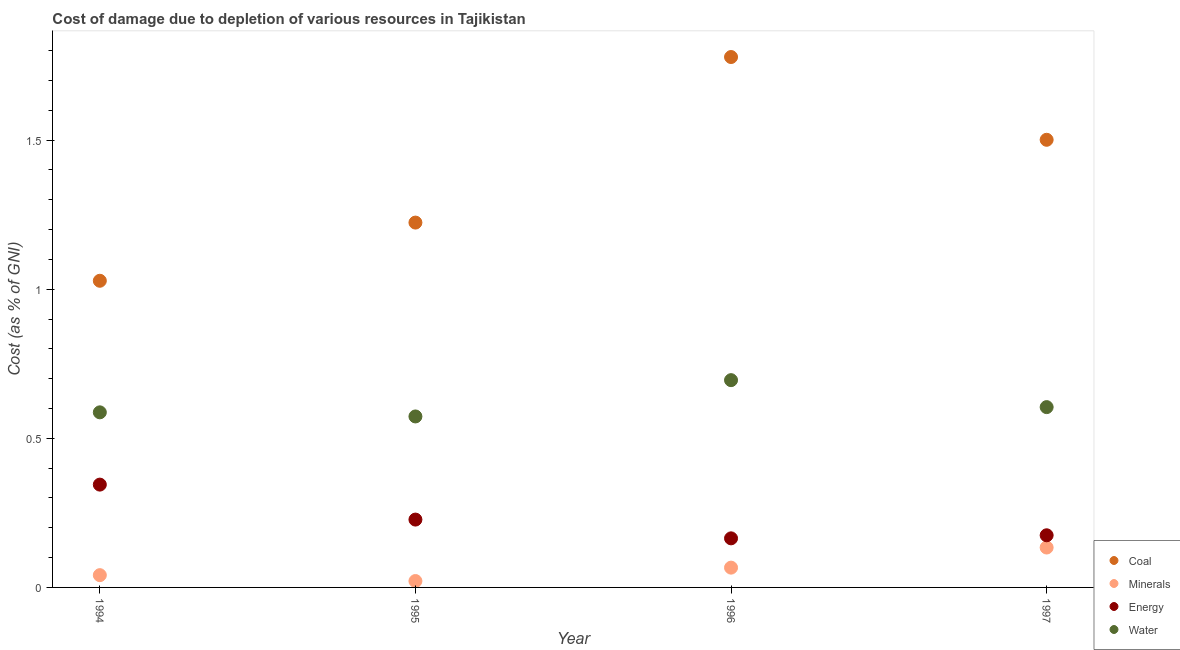What is the cost of damage due to depletion of coal in 1994?
Make the answer very short. 1.03. Across all years, what is the maximum cost of damage due to depletion of minerals?
Offer a terse response. 0.13. Across all years, what is the minimum cost of damage due to depletion of water?
Provide a short and direct response. 0.57. In which year was the cost of damage due to depletion of water maximum?
Offer a terse response. 1996. What is the total cost of damage due to depletion of minerals in the graph?
Your answer should be compact. 0.26. What is the difference between the cost of damage due to depletion of water in 1994 and that in 1996?
Offer a terse response. -0.11. What is the difference between the cost of damage due to depletion of minerals in 1997 and the cost of damage due to depletion of energy in 1994?
Ensure brevity in your answer.  -0.21. What is the average cost of damage due to depletion of energy per year?
Provide a succinct answer. 0.23. In the year 1996, what is the difference between the cost of damage due to depletion of energy and cost of damage due to depletion of minerals?
Keep it short and to the point. 0.1. What is the ratio of the cost of damage due to depletion of coal in 1994 to that in 1997?
Your answer should be very brief. 0.69. Is the difference between the cost of damage due to depletion of energy in 1994 and 1997 greater than the difference between the cost of damage due to depletion of minerals in 1994 and 1997?
Offer a terse response. Yes. What is the difference between the highest and the second highest cost of damage due to depletion of minerals?
Provide a succinct answer. 0.07. What is the difference between the highest and the lowest cost of damage due to depletion of water?
Keep it short and to the point. 0.12. Does the cost of damage due to depletion of coal monotonically increase over the years?
Your answer should be compact. No. Is the cost of damage due to depletion of energy strictly greater than the cost of damage due to depletion of minerals over the years?
Your answer should be very brief. Yes. Are the values on the major ticks of Y-axis written in scientific E-notation?
Give a very brief answer. No. Does the graph contain grids?
Give a very brief answer. No. What is the title of the graph?
Make the answer very short. Cost of damage due to depletion of various resources in Tajikistan . Does "Taxes on revenue" appear as one of the legend labels in the graph?
Your response must be concise. No. What is the label or title of the X-axis?
Ensure brevity in your answer.  Year. What is the label or title of the Y-axis?
Your response must be concise. Cost (as % of GNI). What is the Cost (as % of GNI) of Coal in 1994?
Offer a terse response. 1.03. What is the Cost (as % of GNI) of Minerals in 1994?
Make the answer very short. 0.04. What is the Cost (as % of GNI) of Energy in 1994?
Your answer should be very brief. 0.34. What is the Cost (as % of GNI) of Water in 1994?
Provide a succinct answer. 0.59. What is the Cost (as % of GNI) of Coal in 1995?
Provide a succinct answer. 1.22. What is the Cost (as % of GNI) in Minerals in 1995?
Offer a very short reply. 0.02. What is the Cost (as % of GNI) of Energy in 1995?
Your answer should be very brief. 0.23. What is the Cost (as % of GNI) of Water in 1995?
Ensure brevity in your answer.  0.57. What is the Cost (as % of GNI) of Coal in 1996?
Provide a succinct answer. 1.78. What is the Cost (as % of GNI) of Minerals in 1996?
Provide a short and direct response. 0.07. What is the Cost (as % of GNI) of Energy in 1996?
Keep it short and to the point. 0.16. What is the Cost (as % of GNI) of Water in 1996?
Provide a short and direct response. 0.7. What is the Cost (as % of GNI) of Coal in 1997?
Offer a very short reply. 1.5. What is the Cost (as % of GNI) in Minerals in 1997?
Offer a very short reply. 0.13. What is the Cost (as % of GNI) in Energy in 1997?
Keep it short and to the point. 0.17. What is the Cost (as % of GNI) of Water in 1997?
Offer a very short reply. 0.6. Across all years, what is the maximum Cost (as % of GNI) of Coal?
Ensure brevity in your answer.  1.78. Across all years, what is the maximum Cost (as % of GNI) of Minerals?
Give a very brief answer. 0.13. Across all years, what is the maximum Cost (as % of GNI) of Energy?
Provide a short and direct response. 0.34. Across all years, what is the maximum Cost (as % of GNI) of Water?
Keep it short and to the point. 0.7. Across all years, what is the minimum Cost (as % of GNI) in Coal?
Your response must be concise. 1.03. Across all years, what is the minimum Cost (as % of GNI) of Minerals?
Keep it short and to the point. 0.02. Across all years, what is the minimum Cost (as % of GNI) in Energy?
Ensure brevity in your answer.  0.16. Across all years, what is the minimum Cost (as % of GNI) of Water?
Ensure brevity in your answer.  0.57. What is the total Cost (as % of GNI) of Coal in the graph?
Give a very brief answer. 5.53. What is the total Cost (as % of GNI) in Minerals in the graph?
Offer a very short reply. 0.26. What is the total Cost (as % of GNI) in Energy in the graph?
Your answer should be very brief. 0.91. What is the total Cost (as % of GNI) in Water in the graph?
Provide a succinct answer. 2.46. What is the difference between the Cost (as % of GNI) of Coal in 1994 and that in 1995?
Keep it short and to the point. -0.2. What is the difference between the Cost (as % of GNI) in Minerals in 1994 and that in 1995?
Provide a succinct answer. 0.02. What is the difference between the Cost (as % of GNI) of Energy in 1994 and that in 1995?
Keep it short and to the point. 0.12. What is the difference between the Cost (as % of GNI) of Water in 1994 and that in 1995?
Keep it short and to the point. 0.01. What is the difference between the Cost (as % of GNI) of Coal in 1994 and that in 1996?
Offer a terse response. -0.75. What is the difference between the Cost (as % of GNI) in Minerals in 1994 and that in 1996?
Provide a short and direct response. -0.03. What is the difference between the Cost (as % of GNI) in Energy in 1994 and that in 1996?
Your response must be concise. 0.18. What is the difference between the Cost (as % of GNI) of Water in 1994 and that in 1996?
Give a very brief answer. -0.11. What is the difference between the Cost (as % of GNI) of Coal in 1994 and that in 1997?
Your response must be concise. -0.47. What is the difference between the Cost (as % of GNI) in Minerals in 1994 and that in 1997?
Your answer should be very brief. -0.09. What is the difference between the Cost (as % of GNI) in Energy in 1994 and that in 1997?
Offer a terse response. 0.17. What is the difference between the Cost (as % of GNI) in Water in 1994 and that in 1997?
Offer a terse response. -0.02. What is the difference between the Cost (as % of GNI) in Coal in 1995 and that in 1996?
Your answer should be very brief. -0.56. What is the difference between the Cost (as % of GNI) of Minerals in 1995 and that in 1996?
Your answer should be very brief. -0.04. What is the difference between the Cost (as % of GNI) in Energy in 1995 and that in 1996?
Give a very brief answer. 0.06. What is the difference between the Cost (as % of GNI) in Water in 1995 and that in 1996?
Give a very brief answer. -0.12. What is the difference between the Cost (as % of GNI) of Coal in 1995 and that in 1997?
Provide a succinct answer. -0.28. What is the difference between the Cost (as % of GNI) in Minerals in 1995 and that in 1997?
Provide a short and direct response. -0.11. What is the difference between the Cost (as % of GNI) of Energy in 1995 and that in 1997?
Offer a terse response. 0.05. What is the difference between the Cost (as % of GNI) of Water in 1995 and that in 1997?
Make the answer very short. -0.03. What is the difference between the Cost (as % of GNI) of Coal in 1996 and that in 1997?
Your response must be concise. 0.28. What is the difference between the Cost (as % of GNI) in Minerals in 1996 and that in 1997?
Ensure brevity in your answer.  -0.07. What is the difference between the Cost (as % of GNI) in Energy in 1996 and that in 1997?
Your response must be concise. -0.01. What is the difference between the Cost (as % of GNI) in Water in 1996 and that in 1997?
Provide a succinct answer. 0.09. What is the difference between the Cost (as % of GNI) in Coal in 1994 and the Cost (as % of GNI) in Energy in 1995?
Offer a very short reply. 0.8. What is the difference between the Cost (as % of GNI) of Coal in 1994 and the Cost (as % of GNI) of Water in 1995?
Offer a very short reply. 0.46. What is the difference between the Cost (as % of GNI) in Minerals in 1994 and the Cost (as % of GNI) in Energy in 1995?
Ensure brevity in your answer.  -0.19. What is the difference between the Cost (as % of GNI) in Minerals in 1994 and the Cost (as % of GNI) in Water in 1995?
Offer a terse response. -0.53. What is the difference between the Cost (as % of GNI) of Energy in 1994 and the Cost (as % of GNI) of Water in 1995?
Ensure brevity in your answer.  -0.23. What is the difference between the Cost (as % of GNI) in Coal in 1994 and the Cost (as % of GNI) in Minerals in 1996?
Provide a short and direct response. 0.96. What is the difference between the Cost (as % of GNI) in Coal in 1994 and the Cost (as % of GNI) in Energy in 1996?
Your answer should be compact. 0.86. What is the difference between the Cost (as % of GNI) in Coal in 1994 and the Cost (as % of GNI) in Water in 1996?
Your answer should be very brief. 0.33. What is the difference between the Cost (as % of GNI) in Minerals in 1994 and the Cost (as % of GNI) in Energy in 1996?
Provide a succinct answer. -0.12. What is the difference between the Cost (as % of GNI) in Minerals in 1994 and the Cost (as % of GNI) in Water in 1996?
Your answer should be compact. -0.65. What is the difference between the Cost (as % of GNI) in Energy in 1994 and the Cost (as % of GNI) in Water in 1996?
Provide a short and direct response. -0.35. What is the difference between the Cost (as % of GNI) in Coal in 1994 and the Cost (as % of GNI) in Minerals in 1997?
Your answer should be compact. 0.89. What is the difference between the Cost (as % of GNI) in Coal in 1994 and the Cost (as % of GNI) in Energy in 1997?
Your answer should be very brief. 0.85. What is the difference between the Cost (as % of GNI) in Coal in 1994 and the Cost (as % of GNI) in Water in 1997?
Make the answer very short. 0.42. What is the difference between the Cost (as % of GNI) of Minerals in 1994 and the Cost (as % of GNI) of Energy in 1997?
Provide a short and direct response. -0.13. What is the difference between the Cost (as % of GNI) of Minerals in 1994 and the Cost (as % of GNI) of Water in 1997?
Your answer should be very brief. -0.56. What is the difference between the Cost (as % of GNI) of Energy in 1994 and the Cost (as % of GNI) of Water in 1997?
Provide a short and direct response. -0.26. What is the difference between the Cost (as % of GNI) of Coal in 1995 and the Cost (as % of GNI) of Minerals in 1996?
Give a very brief answer. 1.16. What is the difference between the Cost (as % of GNI) in Coal in 1995 and the Cost (as % of GNI) in Energy in 1996?
Give a very brief answer. 1.06. What is the difference between the Cost (as % of GNI) of Coal in 1995 and the Cost (as % of GNI) of Water in 1996?
Give a very brief answer. 0.53. What is the difference between the Cost (as % of GNI) of Minerals in 1995 and the Cost (as % of GNI) of Energy in 1996?
Give a very brief answer. -0.14. What is the difference between the Cost (as % of GNI) in Minerals in 1995 and the Cost (as % of GNI) in Water in 1996?
Provide a short and direct response. -0.67. What is the difference between the Cost (as % of GNI) in Energy in 1995 and the Cost (as % of GNI) in Water in 1996?
Keep it short and to the point. -0.47. What is the difference between the Cost (as % of GNI) of Coal in 1995 and the Cost (as % of GNI) of Minerals in 1997?
Provide a short and direct response. 1.09. What is the difference between the Cost (as % of GNI) of Coal in 1995 and the Cost (as % of GNI) of Energy in 1997?
Keep it short and to the point. 1.05. What is the difference between the Cost (as % of GNI) of Coal in 1995 and the Cost (as % of GNI) of Water in 1997?
Keep it short and to the point. 0.62. What is the difference between the Cost (as % of GNI) of Minerals in 1995 and the Cost (as % of GNI) of Energy in 1997?
Offer a terse response. -0.15. What is the difference between the Cost (as % of GNI) in Minerals in 1995 and the Cost (as % of GNI) in Water in 1997?
Offer a very short reply. -0.58. What is the difference between the Cost (as % of GNI) of Energy in 1995 and the Cost (as % of GNI) of Water in 1997?
Your response must be concise. -0.38. What is the difference between the Cost (as % of GNI) of Coal in 1996 and the Cost (as % of GNI) of Minerals in 1997?
Keep it short and to the point. 1.65. What is the difference between the Cost (as % of GNI) of Coal in 1996 and the Cost (as % of GNI) of Energy in 1997?
Provide a succinct answer. 1.6. What is the difference between the Cost (as % of GNI) of Coal in 1996 and the Cost (as % of GNI) of Water in 1997?
Your response must be concise. 1.17. What is the difference between the Cost (as % of GNI) of Minerals in 1996 and the Cost (as % of GNI) of Energy in 1997?
Provide a short and direct response. -0.11. What is the difference between the Cost (as % of GNI) in Minerals in 1996 and the Cost (as % of GNI) in Water in 1997?
Your answer should be very brief. -0.54. What is the difference between the Cost (as % of GNI) of Energy in 1996 and the Cost (as % of GNI) of Water in 1997?
Provide a succinct answer. -0.44. What is the average Cost (as % of GNI) in Coal per year?
Make the answer very short. 1.38. What is the average Cost (as % of GNI) of Minerals per year?
Make the answer very short. 0.07. What is the average Cost (as % of GNI) of Energy per year?
Give a very brief answer. 0.23. What is the average Cost (as % of GNI) of Water per year?
Give a very brief answer. 0.62. In the year 1994, what is the difference between the Cost (as % of GNI) in Coal and Cost (as % of GNI) in Minerals?
Offer a terse response. 0.99. In the year 1994, what is the difference between the Cost (as % of GNI) in Coal and Cost (as % of GNI) in Energy?
Provide a succinct answer. 0.68. In the year 1994, what is the difference between the Cost (as % of GNI) in Coal and Cost (as % of GNI) in Water?
Make the answer very short. 0.44. In the year 1994, what is the difference between the Cost (as % of GNI) in Minerals and Cost (as % of GNI) in Energy?
Make the answer very short. -0.3. In the year 1994, what is the difference between the Cost (as % of GNI) of Minerals and Cost (as % of GNI) of Water?
Keep it short and to the point. -0.55. In the year 1994, what is the difference between the Cost (as % of GNI) in Energy and Cost (as % of GNI) in Water?
Your answer should be very brief. -0.24. In the year 1995, what is the difference between the Cost (as % of GNI) of Coal and Cost (as % of GNI) of Minerals?
Provide a succinct answer. 1.2. In the year 1995, what is the difference between the Cost (as % of GNI) of Coal and Cost (as % of GNI) of Energy?
Provide a succinct answer. 1. In the year 1995, what is the difference between the Cost (as % of GNI) of Coal and Cost (as % of GNI) of Water?
Give a very brief answer. 0.65. In the year 1995, what is the difference between the Cost (as % of GNI) in Minerals and Cost (as % of GNI) in Energy?
Keep it short and to the point. -0.21. In the year 1995, what is the difference between the Cost (as % of GNI) in Minerals and Cost (as % of GNI) in Water?
Provide a short and direct response. -0.55. In the year 1995, what is the difference between the Cost (as % of GNI) of Energy and Cost (as % of GNI) of Water?
Keep it short and to the point. -0.35. In the year 1996, what is the difference between the Cost (as % of GNI) in Coal and Cost (as % of GNI) in Minerals?
Keep it short and to the point. 1.71. In the year 1996, what is the difference between the Cost (as % of GNI) in Coal and Cost (as % of GNI) in Energy?
Provide a short and direct response. 1.61. In the year 1996, what is the difference between the Cost (as % of GNI) of Coal and Cost (as % of GNI) of Water?
Provide a succinct answer. 1.08. In the year 1996, what is the difference between the Cost (as % of GNI) in Minerals and Cost (as % of GNI) in Energy?
Your answer should be very brief. -0.1. In the year 1996, what is the difference between the Cost (as % of GNI) in Minerals and Cost (as % of GNI) in Water?
Give a very brief answer. -0.63. In the year 1996, what is the difference between the Cost (as % of GNI) of Energy and Cost (as % of GNI) of Water?
Offer a terse response. -0.53. In the year 1997, what is the difference between the Cost (as % of GNI) of Coal and Cost (as % of GNI) of Minerals?
Offer a terse response. 1.37. In the year 1997, what is the difference between the Cost (as % of GNI) of Coal and Cost (as % of GNI) of Energy?
Keep it short and to the point. 1.33. In the year 1997, what is the difference between the Cost (as % of GNI) in Coal and Cost (as % of GNI) in Water?
Offer a very short reply. 0.9. In the year 1997, what is the difference between the Cost (as % of GNI) in Minerals and Cost (as % of GNI) in Energy?
Your answer should be very brief. -0.04. In the year 1997, what is the difference between the Cost (as % of GNI) in Minerals and Cost (as % of GNI) in Water?
Ensure brevity in your answer.  -0.47. In the year 1997, what is the difference between the Cost (as % of GNI) of Energy and Cost (as % of GNI) of Water?
Offer a very short reply. -0.43. What is the ratio of the Cost (as % of GNI) in Coal in 1994 to that in 1995?
Make the answer very short. 0.84. What is the ratio of the Cost (as % of GNI) of Minerals in 1994 to that in 1995?
Your response must be concise. 1.92. What is the ratio of the Cost (as % of GNI) of Energy in 1994 to that in 1995?
Give a very brief answer. 1.52. What is the ratio of the Cost (as % of GNI) of Water in 1994 to that in 1995?
Offer a terse response. 1.02. What is the ratio of the Cost (as % of GNI) in Coal in 1994 to that in 1996?
Offer a terse response. 0.58. What is the ratio of the Cost (as % of GNI) in Minerals in 1994 to that in 1996?
Give a very brief answer. 0.62. What is the ratio of the Cost (as % of GNI) of Energy in 1994 to that in 1996?
Your response must be concise. 2.09. What is the ratio of the Cost (as % of GNI) of Water in 1994 to that in 1996?
Offer a very short reply. 0.84. What is the ratio of the Cost (as % of GNI) of Coal in 1994 to that in 1997?
Make the answer very short. 0.69. What is the ratio of the Cost (as % of GNI) of Minerals in 1994 to that in 1997?
Give a very brief answer. 0.31. What is the ratio of the Cost (as % of GNI) in Energy in 1994 to that in 1997?
Give a very brief answer. 1.97. What is the ratio of the Cost (as % of GNI) in Water in 1994 to that in 1997?
Make the answer very short. 0.97. What is the ratio of the Cost (as % of GNI) in Coal in 1995 to that in 1996?
Ensure brevity in your answer.  0.69. What is the ratio of the Cost (as % of GNI) in Minerals in 1995 to that in 1996?
Your response must be concise. 0.32. What is the ratio of the Cost (as % of GNI) in Energy in 1995 to that in 1996?
Keep it short and to the point. 1.38. What is the ratio of the Cost (as % of GNI) in Water in 1995 to that in 1996?
Provide a short and direct response. 0.82. What is the ratio of the Cost (as % of GNI) in Coal in 1995 to that in 1997?
Ensure brevity in your answer.  0.81. What is the ratio of the Cost (as % of GNI) in Minerals in 1995 to that in 1997?
Ensure brevity in your answer.  0.16. What is the ratio of the Cost (as % of GNI) of Energy in 1995 to that in 1997?
Provide a succinct answer. 1.3. What is the ratio of the Cost (as % of GNI) of Water in 1995 to that in 1997?
Provide a short and direct response. 0.95. What is the ratio of the Cost (as % of GNI) of Coal in 1996 to that in 1997?
Offer a terse response. 1.18. What is the ratio of the Cost (as % of GNI) in Minerals in 1996 to that in 1997?
Provide a succinct answer. 0.5. What is the ratio of the Cost (as % of GNI) in Water in 1996 to that in 1997?
Your answer should be very brief. 1.15. What is the difference between the highest and the second highest Cost (as % of GNI) in Coal?
Your answer should be compact. 0.28. What is the difference between the highest and the second highest Cost (as % of GNI) of Minerals?
Offer a terse response. 0.07. What is the difference between the highest and the second highest Cost (as % of GNI) of Energy?
Make the answer very short. 0.12. What is the difference between the highest and the second highest Cost (as % of GNI) of Water?
Your answer should be compact. 0.09. What is the difference between the highest and the lowest Cost (as % of GNI) of Coal?
Ensure brevity in your answer.  0.75. What is the difference between the highest and the lowest Cost (as % of GNI) in Minerals?
Provide a short and direct response. 0.11. What is the difference between the highest and the lowest Cost (as % of GNI) of Energy?
Keep it short and to the point. 0.18. What is the difference between the highest and the lowest Cost (as % of GNI) of Water?
Your answer should be very brief. 0.12. 